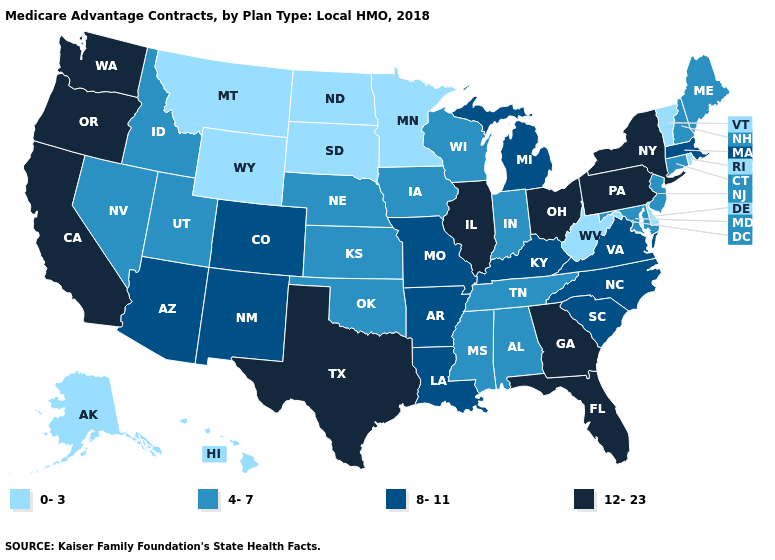What is the lowest value in states that border Utah?
Give a very brief answer. 0-3. What is the lowest value in the USA?
Give a very brief answer. 0-3. What is the highest value in the USA?
Write a very short answer. 12-23. What is the lowest value in the South?
Keep it brief. 0-3. What is the highest value in the USA?
Write a very short answer. 12-23. Which states have the highest value in the USA?
Concise answer only. California, Florida, Georgia, Illinois, New York, Ohio, Oregon, Pennsylvania, Texas, Washington. Name the states that have a value in the range 12-23?
Answer briefly. California, Florida, Georgia, Illinois, New York, Ohio, Oregon, Pennsylvania, Texas, Washington. Does South Dakota have the highest value in the USA?
Be succinct. No. Name the states that have a value in the range 12-23?
Concise answer only. California, Florida, Georgia, Illinois, New York, Ohio, Oregon, Pennsylvania, Texas, Washington. Does the first symbol in the legend represent the smallest category?
Be succinct. Yes. Does Minnesota have the lowest value in the MidWest?
Short answer required. Yes. Does Minnesota have the same value as Georgia?
Be succinct. No. What is the value of Maryland?
Be succinct. 4-7. What is the highest value in the USA?
Be succinct. 12-23. Which states have the lowest value in the USA?
Keep it brief. Alaska, Delaware, Hawaii, Minnesota, Montana, North Dakota, Rhode Island, South Dakota, Vermont, West Virginia, Wyoming. 